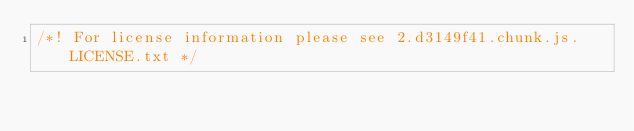Convert code to text. <code><loc_0><loc_0><loc_500><loc_500><_JavaScript_>/*! For license information please see 2.d3149f41.chunk.js.LICENSE.txt */</code> 